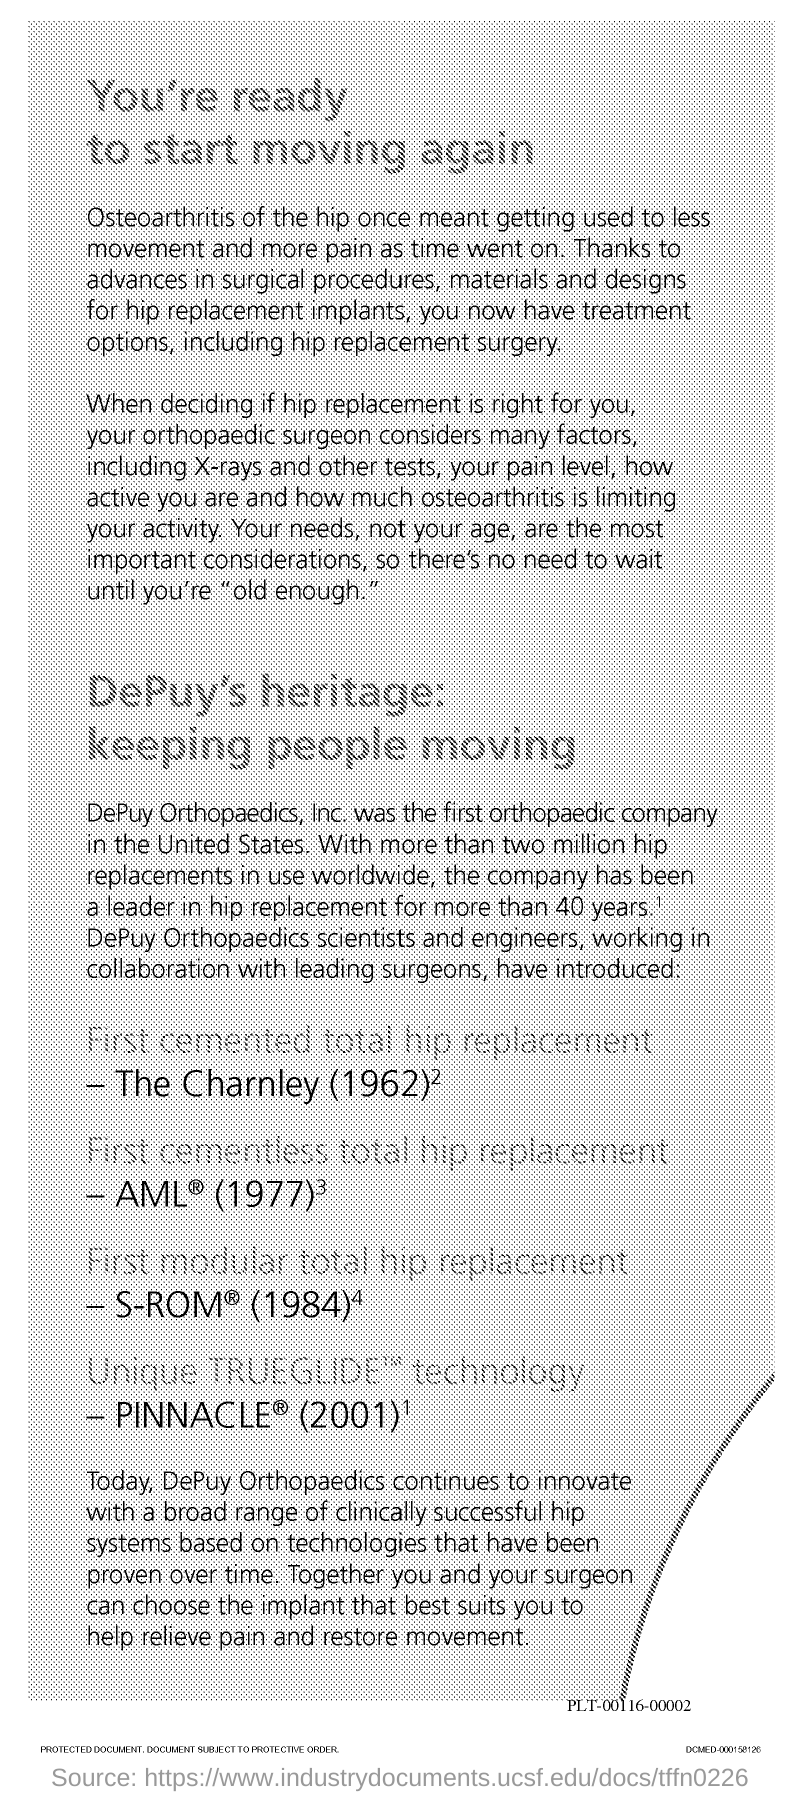Which was the first orthopaedic company in the United States?
Provide a succinct answer. DePuy Orthopaedics, Inc. 